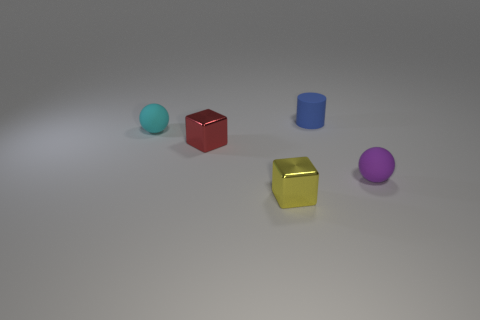Are the small block that is behind the tiny purple sphere and the blue cylinder left of the purple matte thing made of the same material?
Your response must be concise. No. What is the size of the matte ball behind the small shiny object to the left of the yellow metallic block?
Offer a very short reply. Small. Is there anything else that is the same size as the blue rubber thing?
Offer a terse response. Yes. There is another tiny thing that is the same shape as the small purple thing; what is it made of?
Offer a very short reply. Rubber. Do the matte thing that is on the right side of the small blue thing and the cyan matte object that is on the left side of the blue cylinder have the same shape?
Your response must be concise. Yes. Are there more large brown rubber cylinders than cyan balls?
Your response must be concise. No. The red cube has what size?
Provide a succinct answer. Small. Does the small ball that is on the right side of the small red block have the same material as the blue object?
Your response must be concise. Yes. Is the number of rubber objects in front of the red cube less than the number of cylinders that are right of the small cylinder?
Offer a very short reply. No. What number of other things are the same material as the small yellow cube?
Your answer should be very brief. 1. 